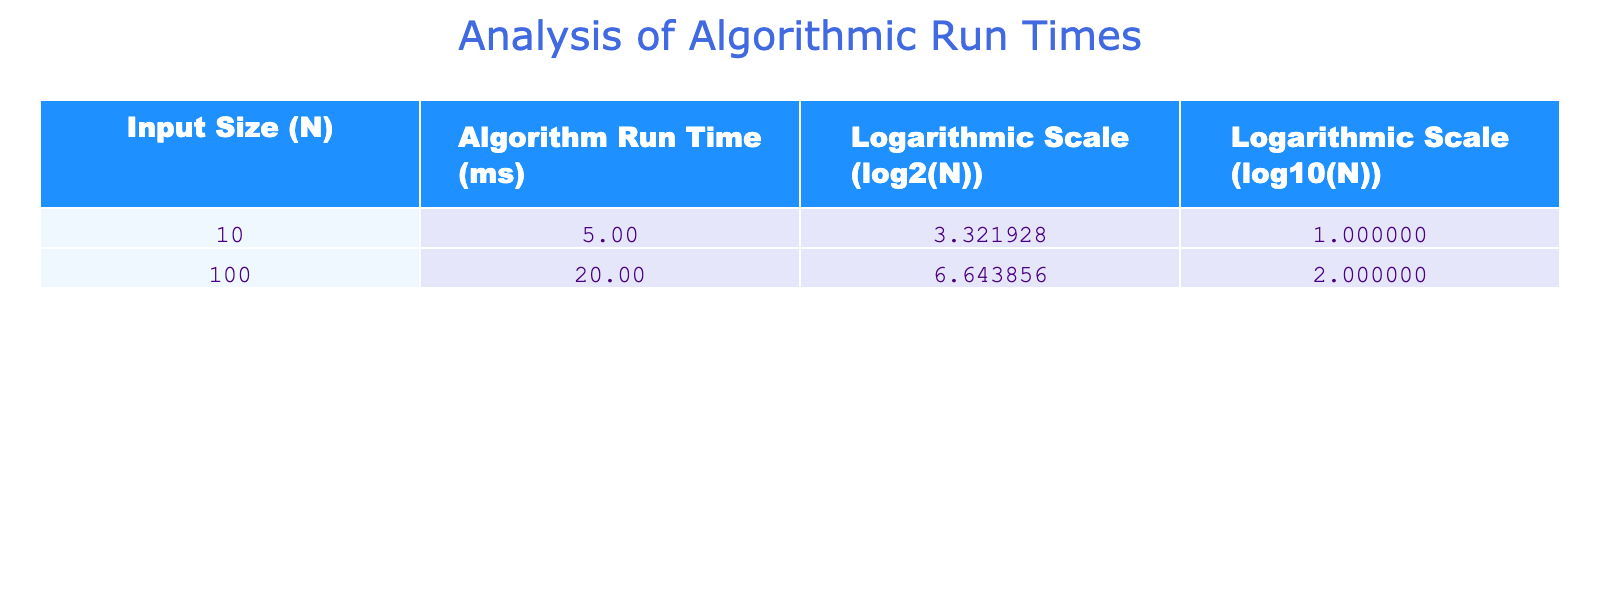What is the algorithm run time for an input size of 10? Referring to the table, the algorithm run time for an input size of 10 is directly listed in the column for Algorithm Run Time (ms), which shows a value of 5 milliseconds.
Answer: 5 ms What is the logarithmic scale value (log2) for an input size of 100? The logarithmic scale value (log2) corresponds to the input size of 100, which is found in the Logarithmic Scale (log2(N)) column, showing a value of 6.643856.
Answer: 6.643856 Is the run time for input size 100 greater than that for input size 10? Comparing the values from the Algorithm Run Time (ms) column, the run time for input size 100 is 20 ms, while for input size 10 it is 5 ms. Since 20 is greater than 5, the statement is true.
Answer: Yes What is the difference in algorithm run time between input sizes 100 and 10? The algorithm run time for input size 100 is 20 ms and for input size 10 is 5 ms. The difference is calculated by subtracting the smaller value from the larger value: 20 ms - 5 ms = 15 ms.
Answer: 15 ms What is the average logarithmic scale value (log10) for the provided input sizes? To find the average, we take the values of log10 for input sizes of 10 and 100, which are 1.000000 and 2.000000 respectively. Adding these gives 3.000000, and dividing by the number of values (2) gives an average of 3.000000 / 2 = 1.500000.
Answer: 1.500000 Is the logarithmic scale value (log2) for an input size of 10 greater than that for input size 100? The log2 value for input size 10 is 3.321928, while for input size 100 it is 6.643856. Since 3.321928 is less than 6.643856, the statement is false.
Answer: No What is the total run time for both input sizes combined? To find the total run time, we add the algorithm run times for input sizes 10 and 100: 5 ms + 20 ms = 25 ms.
Answer: 25 ms How much is the logarithmic scale value (log2) for input size 100 larger than that for input size 10? The value of log2 for input size 100 is 6.643856 and for input size 10 it is 3.321928. The difference is calculated as 6.643856 - 3.321928 = 3.321928.
Answer: 3.321928 